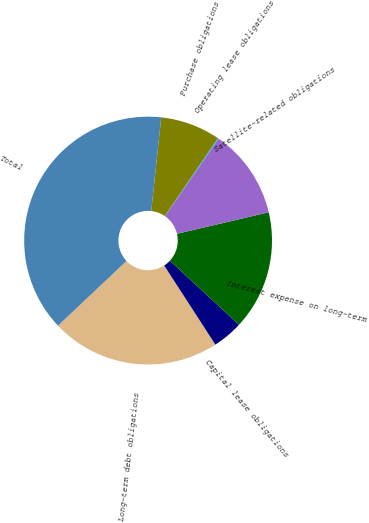Convert chart. <chart><loc_0><loc_0><loc_500><loc_500><pie_chart><fcel>Long-term debt obligations<fcel>Capital lease obligations<fcel>Interest expense on long-term<fcel>Satellite-related obligations<fcel>Operating lease obligations<fcel>Purchase obligations<fcel>Total<nl><fcel>22.09%<fcel>3.97%<fcel>15.56%<fcel>11.7%<fcel>0.11%<fcel>7.83%<fcel>38.74%<nl></chart> 